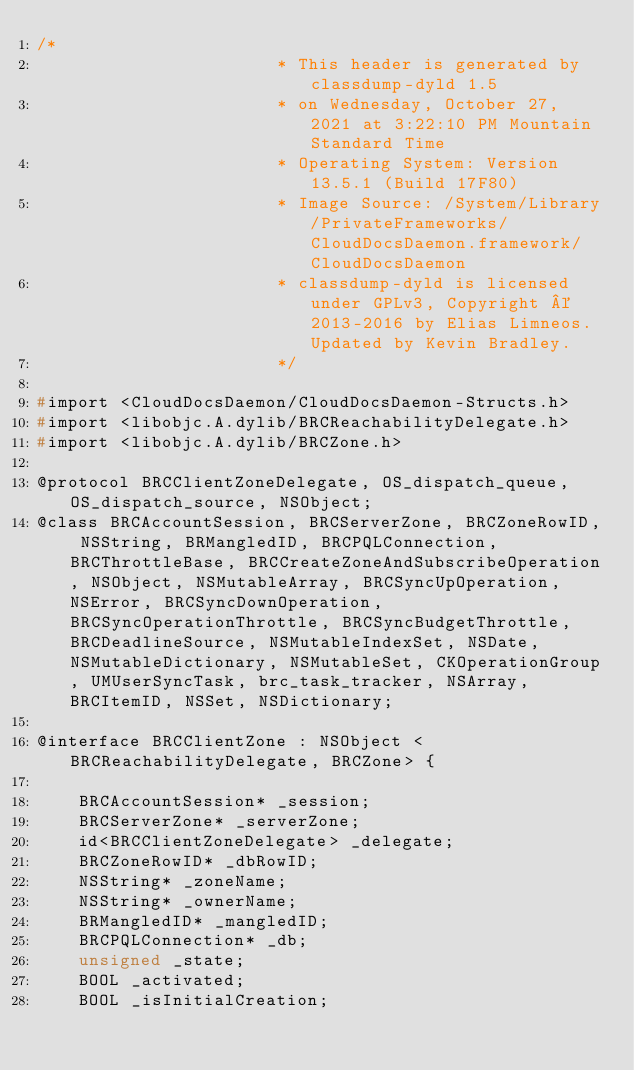Convert code to text. <code><loc_0><loc_0><loc_500><loc_500><_C_>/*
                       * This header is generated by classdump-dyld 1.5
                       * on Wednesday, October 27, 2021 at 3:22:10 PM Mountain Standard Time
                       * Operating System: Version 13.5.1 (Build 17F80)
                       * Image Source: /System/Library/PrivateFrameworks/CloudDocsDaemon.framework/CloudDocsDaemon
                       * classdump-dyld is licensed under GPLv3, Copyright © 2013-2016 by Elias Limneos. Updated by Kevin Bradley.
                       */

#import <CloudDocsDaemon/CloudDocsDaemon-Structs.h>
#import <libobjc.A.dylib/BRCReachabilityDelegate.h>
#import <libobjc.A.dylib/BRCZone.h>

@protocol BRCClientZoneDelegate, OS_dispatch_queue, OS_dispatch_source, NSObject;
@class BRCAccountSession, BRCServerZone, BRCZoneRowID, NSString, BRMangledID, BRCPQLConnection, BRCThrottleBase, BRCCreateZoneAndSubscribeOperation, NSObject, NSMutableArray, BRCSyncUpOperation, NSError, BRCSyncDownOperation, BRCSyncOperationThrottle, BRCSyncBudgetThrottle, BRCDeadlineSource, NSMutableIndexSet, NSDate, NSMutableDictionary, NSMutableSet, CKOperationGroup, UMUserSyncTask, brc_task_tracker, NSArray, BRCItemID, NSSet, NSDictionary;

@interface BRCClientZone : NSObject <BRCReachabilityDelegate, BRCZone> {

	BRCAccountSession* _session;
	BRCServerZone* _serverZone;
	id<BRCClientZoneDelegate> _delegate;
	BRCZoneRowID* _dbRowID;
	NSString* _zoneName;
	NSString* _ownerName;
	BRMangledID* _mangledID;
	BRCPQLConnection* _db;
	unsigned _state;
	BOOL _activated;
	BOOL _isInitialCreation;</code> 